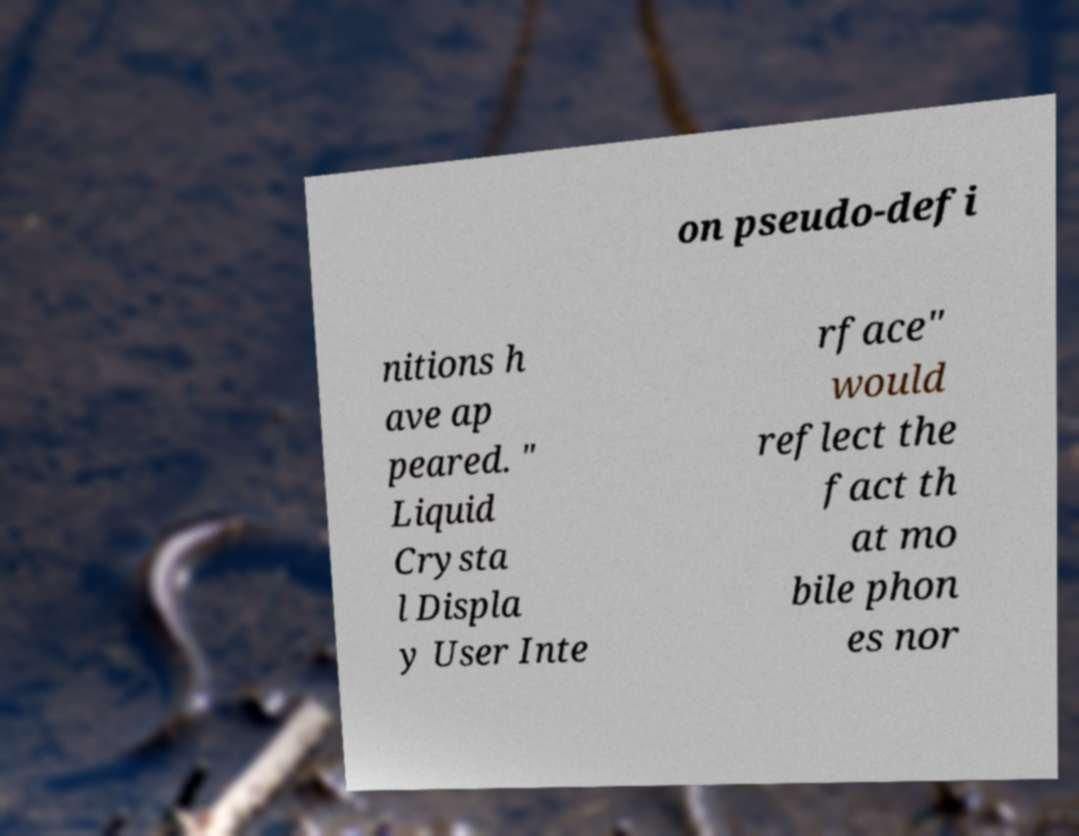There's text embedded in this image that I need extracted. Can you transcribe it verbatim? on pseudo-defi nitions h ave ap peared. " Liquid Crysta l Displa y User Inte rface" would reflect the fact th at mo bile phon es nor 